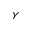Convert formula to latex. <formula><loc_0><loc_0><loc_500><loc_500>\gamma</formula> 